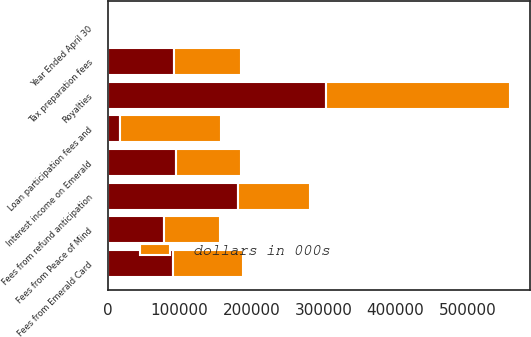Convert chart. <chart><loc_0><loc_0><loc_500><loc_500><stacked_bar_chart><ecel><fcel>Year Ended April 30<fcel>Tax preparation fees<fcel>Royalties<fcel>Fees from refund anticipation<fcel>Interest income on Emerald<fcel>Fees from Emerald Card<fcel>Fees from Peace of Mind<fcel>Loan participation fees and<nl><fcel>nan<fcel>2011<fcel>92655<fcel>304194<fcel>181661<fcel>94300<fcel>90451<fcel>78413<fcel>17151<nl><fcel>dollars in 000s<fcel>2009<fcel>92655<fcel>255536<fcel>100021<fcel>91010<fcel>98031<fcel>78205<fcel>139770<nl></chart> 